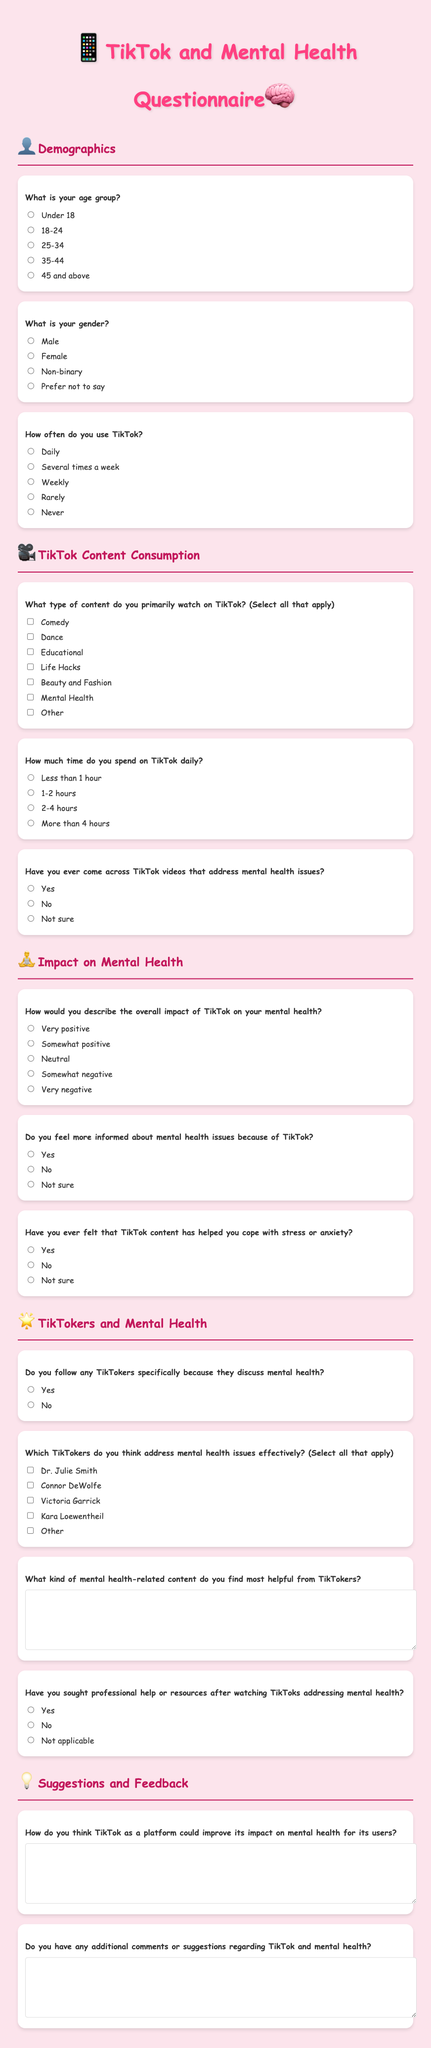What is the title of the questionnaire? The title of the questionnaire is the main heading in the document, which is "TikTok and Mental Health Questionnaire."
Answer: TikTok and Mental Health Questionnaire How many demographics questions are included in the document? The document contains three questions under the demographics section.
Answer: 3 What is the first question regarding TikTok content consumption? The first question regarding TikTok content consumption asks about the type of content primarily watched on TikTok.
Answer: What type of content do you primarily watch on TikTok? Which TikToker is listed as addressing mental health issues effectively? The document lists "Dr. Julie Smith" as one of the TikTokers who addresses mental health issues effectively.
Answer: Dr. Julie Smith What type of response format is used for the question about the overall impact of TikTok on mental health? This question uses a multiple-choice response format with radio buttons for selection.
Answer: Radio buttons What is the emoji used in the title of the questionnaire? The title features two emojis: a phone emoji and a brain emoji.
Answer: 📱, 🧠 Do users need to specify their gender in the questionnaire? Yes, there is a question that asks for the respondent's gender with multiple choice options.
Answer: Yes How can participants provide suggestions for improvement regarding TikTok? Participants can provide suggestions through a text area specifically designed for improvement suggestions.
Answer: Text area What is the maximum possible duration one might indicate for TikTok usage daily? The maximum duration indicated for TikTok usage daily is "More than 4 hours."
Answer: More than 4 hours 